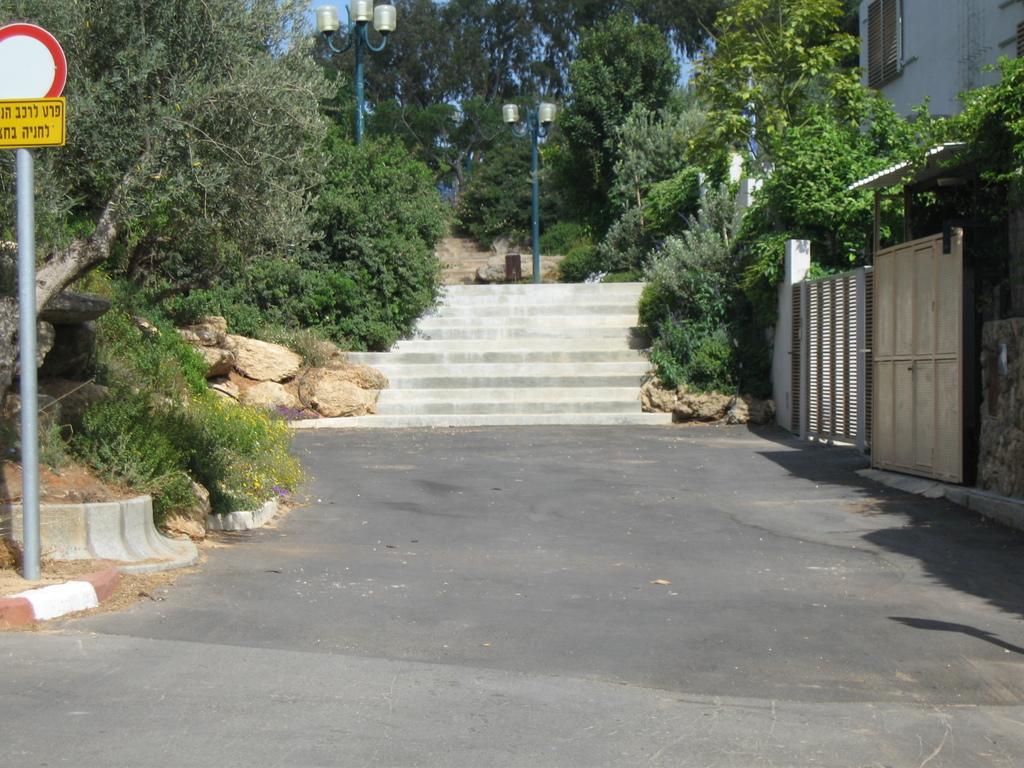How would you summarize this image in a sentence or two? In this image I can see the road, a pole, a board to the pole, few trees, few stairs, few street light poles and a building. I can see few rocks and a white colored gate. In the background I can see the sky. 